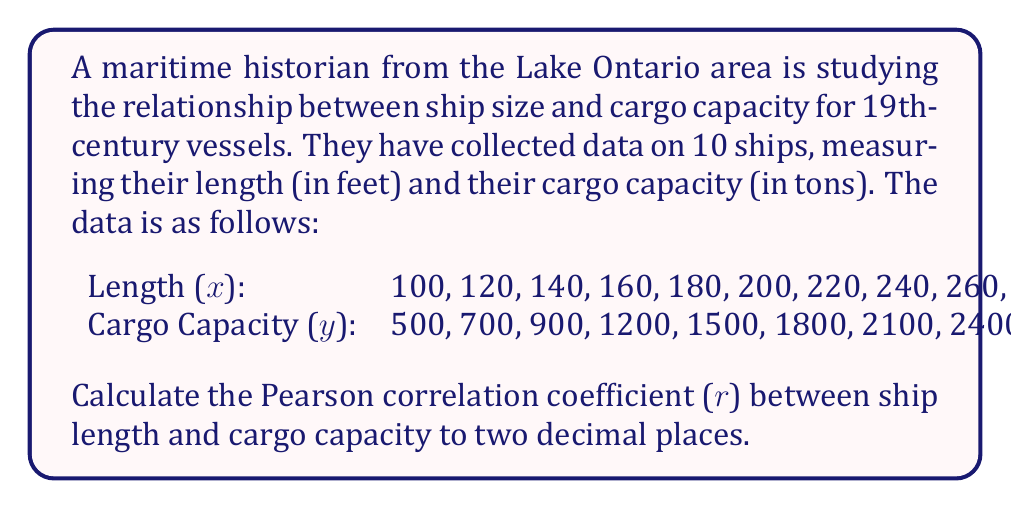Can you answer this question? To calculate the Pearson correlation coefficient (r), we'll use the formula:

$$ r = \frac{n\sum xy - \sum x \sum y}{\sqrt{[n\sum x^2 - (\sum x)^2][n\sum y^2 - (\sum y)^2]}} $$

Where n is the number of data points.

Step 1: Calculate the sums and squared sums:
$\sum x = 1900$
$\sum y = 16800$
$\sum xy = 3,640,000$
$\sum x^2 = 401,000$
$\sum y^2 = 33,870,000$

Step 2: Substitute these values into the formula:

$$ r = \frac{10(3,640,000) - (1900)(16800)}{\sqrt{[10(401,000) - (1900)^2][10(33,870,000) - (16800)^2]}} $$

Step 3: Simplify:

$$ r = \frac{36,400,000 - 31,920,000}{\sqrt{(4,010,000 - 3,610,000)(338,700,000 - 282,240,000)}} $$

$$ r = \frac{4,480,000}{\sqrt{(400,000)(56,460,000)}} $$

$$ r = \frac{4,480,000}{\sqrt{22,584,000,000,000}} $$

$$ r = \frac{4,480,000}{4,752,262.81} $$

$$ r \approx 0.9427 $$

Step 4: Round to two decimal places:

$$ r \approx 0.94 $$
Answer: 0.94 